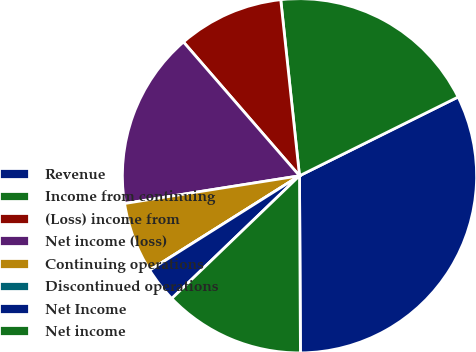<chart> <loc_0><loc_0><loc_500><loc_500><pie_chart><fcel>Revenue<fcel>Income from continuing<fcel>(Loss) income from<fcel>Net income (loss)<fcel>Continuing operations<fcel>Discontinued operations<fcel>Net Income<fcel>Net income<nl><fcel>32.25%<fcel>19.35%<fcel>9.68%<fcel>16.13%<fcel>6.45%<fcel>0.0%<fcel>3.23%<fcel>12.9%<nl></chart> 